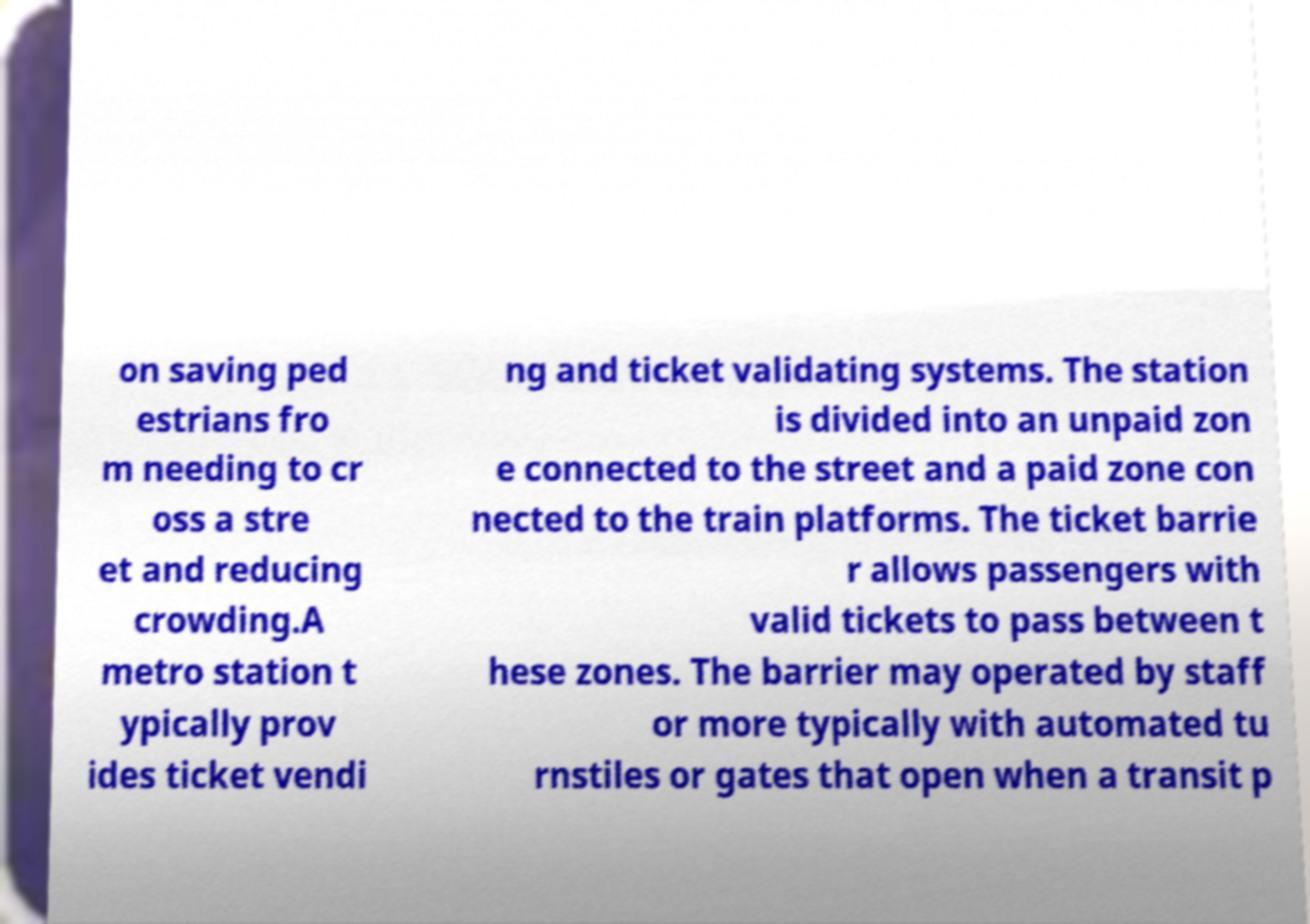There's text embedded in this image that I need extracted. Can you transcribe it verbatim? on saving ped estrians fro m needing to cr oss a stre et and reducing crowding.A metro station t ypically prov ides ticket vendi ng and ticket validating systems. The station is divided into an unpaid zon e connected to the street and a paid zone con nected to the train platforms. The ticket barrie r allows passengers with valid tickets to pass between t hese zones. The barrier may operated by staff or more typically with automated tu rnstiles or gates that open when a transit p 